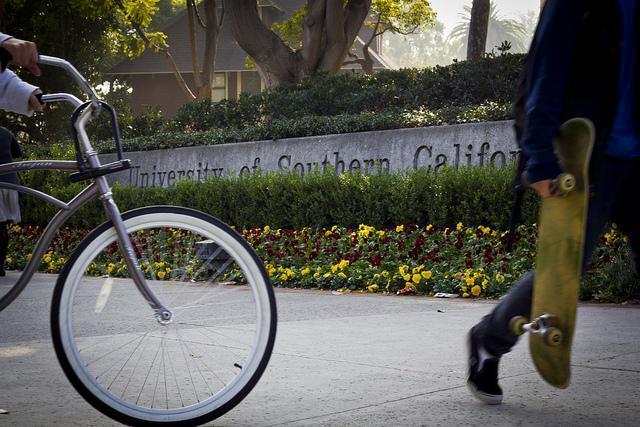How many people can you see?
Give a very brief answer. 2. How many bottles on the cutting board are uncorked?
Give a very brief answer. 0. 